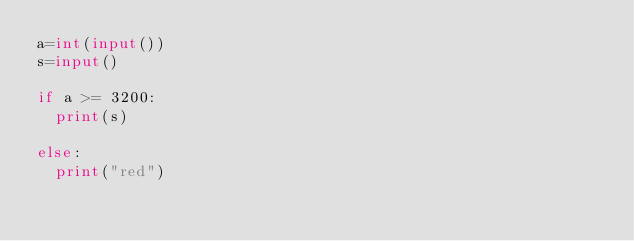<code> <loc_0><loc_0><loc_500><loc_500><_Python_>a=int(input())
s=input()

if a >= 3200:
  print(s)

else:
  print("red")</code> 